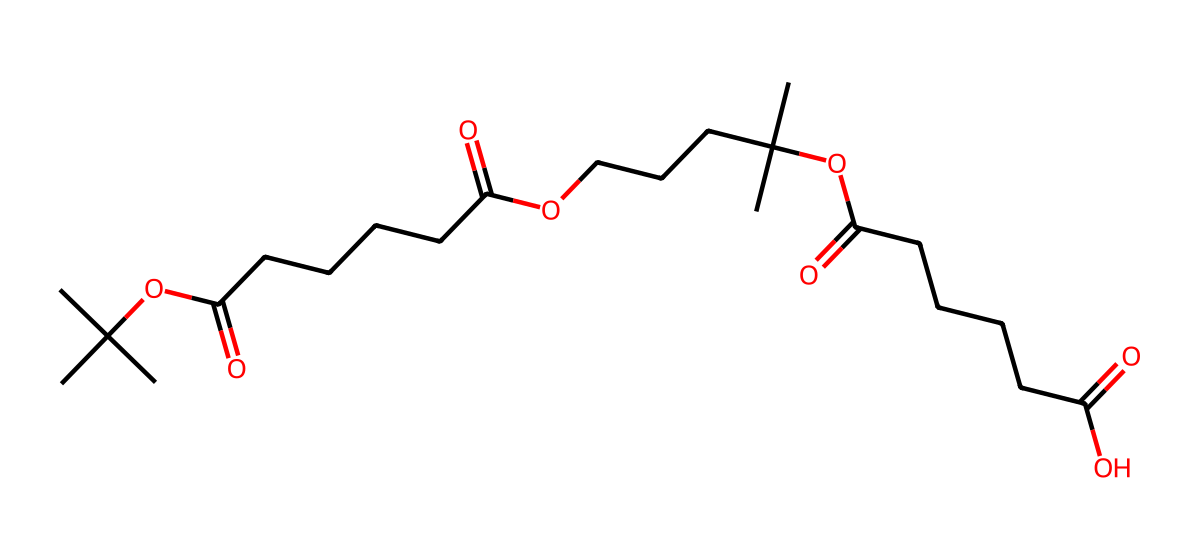what is the total number of carbon atoms in this chemical? To determine the total number of carbon atoms, we can analyze the SMILES representation. The "C" characters represent carbon atoms, and by counting them in the provided structure, we find a total of 20 carbon atoms.
Answer: 20 how many ester functional groups are present in this molecule? In the SMILES notation, the presence of "OC(=O)" indicates ester functional groups. By examining the structure, we can identify two occurrences of this motif, indicating that there are 2 ester functional groups in the molecule.
Answer: 2 what is the main organic functionality of this chemical? The molecule contains both ester and carboxylic acid groups, with the distinct motif of "OC(=O)" for esters and "C(=O)O" indicating a carboxylic acid. Since the dominant features in biodegradable polymers are their ester linkages, the main functionality can be identified as esters.
Answer: esters what is the longest carbon chain length in this polymer? By analyzing the structure in the SMILES representation, the longest continuous chain of carbon atoms is found connected to the ester and carboxylic acid functionalities, which appears to have a length of 5 carbon atoms.
Answer: 5 how many branches are present in the carbon skeleton? The structure shows several branched groups marked by "(C)(C)" in the notation. Each branching indicates a presence of a methyl group. Counting these shows that there are 4 branched methyl groups in the polymer structure.
Answer: 4 what type of polymer does this structure likely represent? The presence of repeatable ester groups along with long carbon chains indicates that this molecule can function as a poly(ester). Hence, it represents a thermoplastic biodegradable polymer, commonly used in eco-friendly applications.
Answer: poly(ester) is this compound likely to be soluble in water? The presence of carboxylic acid groups could suggest some solubility due to potential hydrogen bonding with water. However, the substantial hydrocarbon chain length typically results in limited solubility. Thus, the overall nature of the compound indicates that it is likely to have low solubility in water.
Answer: low 